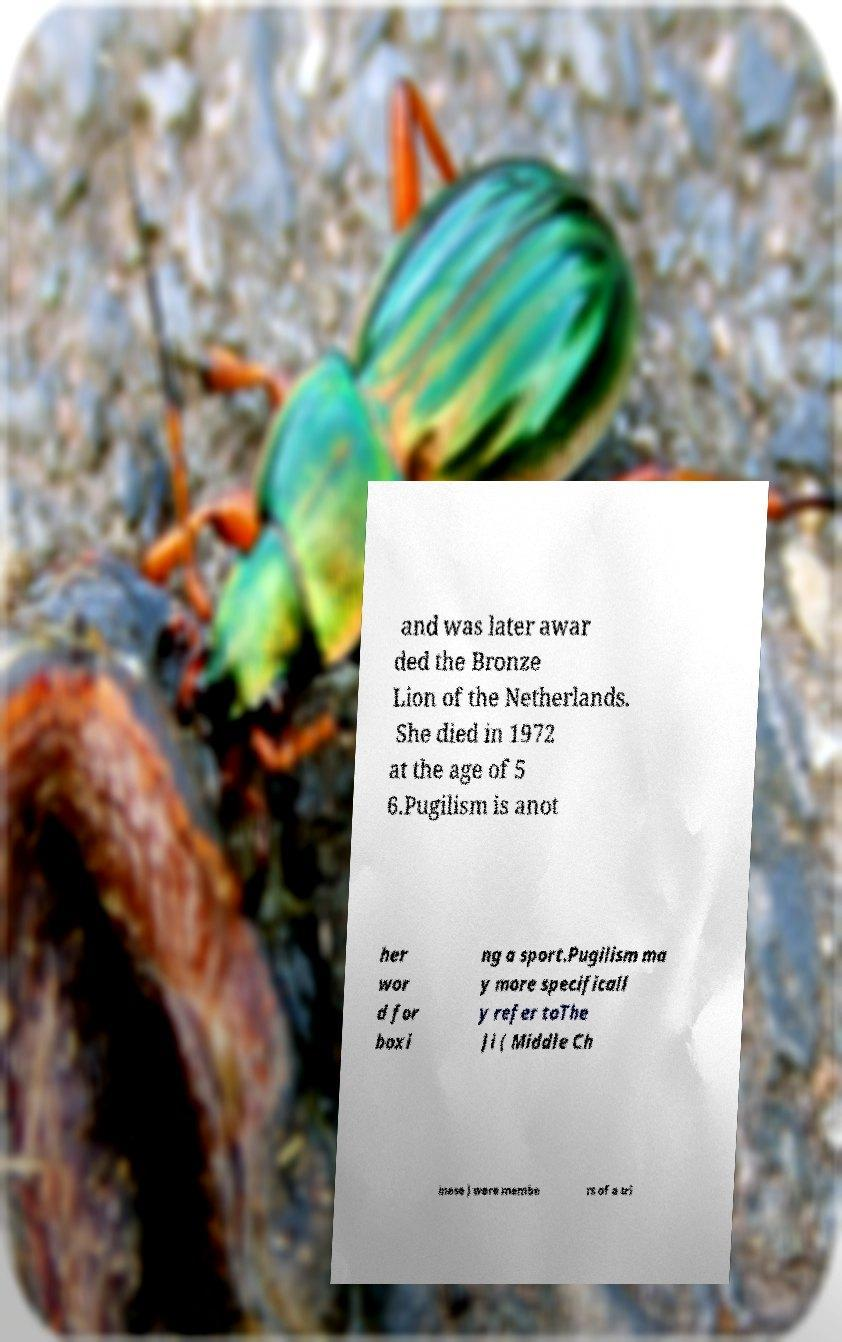Could you assist in decoding the text presented in this image and type it out clearly? and was later awar ded the Bronze Lion of the Netherlands. She died in 1972 at the age of 5 6.Pugilism is anot her wor d for boxi ng a sport.Pugilism ma y more specificall y refer toThe Ji ( Middle Ch inese ) were membe rs of a tri 